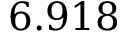<formula> <loc_0><loc_0><loc_500><loc_500>6 . 9 1 8</formula> 